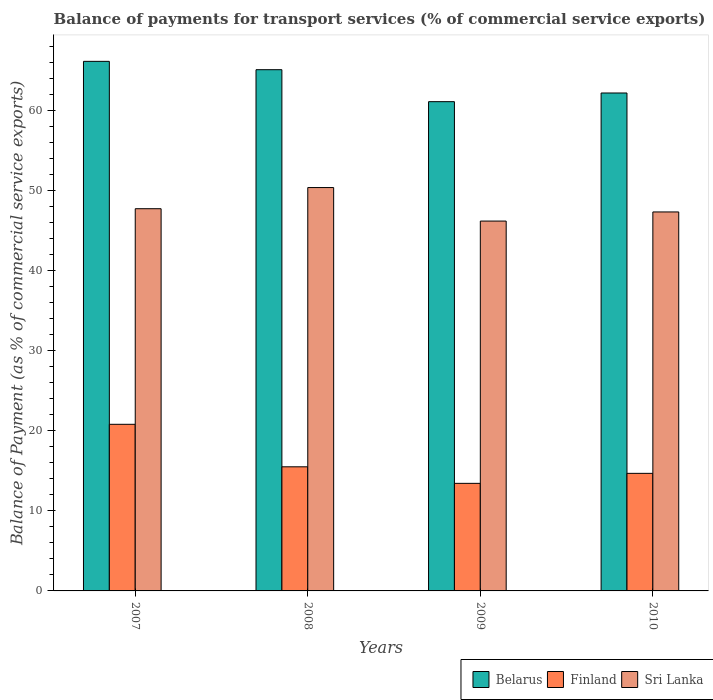Are the number of bars on each tick of the X-axis equal?
Your answer should be compact. Yes. How many bars are there on the 3rd tick from the right?
Provide a succinct answer. 3. What is the label of the 1st group of bars from the left?
Offer a very short reply. 2007. In how many cases, is the number of bars for a given year not equal to the number of legend labels?
Your answer should be very brief. 0. What is the balance of payments for transport services in Finland in 2007?
Provide a short and direct response. 20.81. Across all years, what is the maximum balance of payments for transport services in Sri Lanka?
Make the answer very short. 50.39. Across all years, what is the minimum balance of payments for transport services in Belarus?
Provide a short and direct response. 61.12. In which year was the balance of payments for transport services in Sri Lanka maximum?
Ensure brevity in your answer.  2008. What is the total balance of payments for transport services in Belarus in the graph?
Offer a very short reply. 254.58. What is the difference between the balance of payments for transport services in Finland in 2009 and that in 2010?
Give a very brief answer. -1.25. What is the difference between the balance of payments for transport services in Belarus in 2008 and the balance of payments for transport services in Sri Lanka in 2009?
Make the answer very short. 18.91. What is the average balance of payments for transport services in Belarus per year?
Offer a terse response. 63.65. In the year 2007, what is the difference between the balance of payments for transport services in Sri Lanka and balance of payments for transport services in Finland?
Offer a terse response. 26.93. What is the ratio of the balance of payments for transport services in Belarus in 2007 to that in 2009?
Your answer should be compact. 1.08. Is the balance of payments for transport services in Sri Lanka in 2007 less than that in 2010?
Offer a terse response. No. Is the difference between the balance of payments for transport services in Sri Lanka in 2007 and 2009 greater than the difference between the balance of payments for transport services in Finland in 2007 and 2009?
Give a very brief answer. No. What is the difference between the highest and the second highest balance of payments for transport services in Sri Lanka?
Provide a succinct answer. 2.64. What is the difference between the highest and the lowest balance of payments for transport services in Finland?
Offer a terse response. 7.38. What does the 3rd bar from the right in 2007 represents?
Your answer should be very brief. Belarus. Is it the case that in every year, the sum of the balance of payments for transport services in Belarus and balance of payments for transport services in Sri Lanka is greater than the balance of payments for transport services in Finland?
Your answer should be compact. Yes. How many bars are there?
Provide a short and direct response. 12. What is the difference between two consecutive major ticks on the Y-axis?
Give a very brief answer. 10. What is the title of the graph?
Provide a short and direct response. Balance of payments for transport services (% of commercial service exports). Does "Venezuela" appear as one of the legend labels in the graph?
Your response must be concise. No. What is the label or title of the X-axis?
Provide a succinct answer. Years. What is the label or title of the Y-axis?
Provide a succinct answer. Balance of Payment (as % of commercial service exports). What is the Balance of Payment (as % of commercial service exports) in Belarus in 2007?
Your answer should be compact. 66.15. What is the Balance of Payment (as % of commercial service exports) in Finland in 2007?
Make the answer very short. 20.81. What is the Balance of Payment (as % of commercial service exports) in Sri Lanka in 2007?
Offer a very short reply. 47.75. What is the Balance of Payment (as % of commercial service exports) in Belarus in 2008?
Your answer should be very brief. 65.11. What is the Balance of Payment (as % of commercial service exports) in Finland in 2008?
Make the answer very short. 15.5. What is the Balance of Payment (as % of commercial service exports) of Sri Lanka in 2008?
Your answer should be compact. 50.39. What is the Balance of Payment (as % of commercial service exports) of Belarus in 2009?
Your answer should be compact. 61.12. What is the Balance of Payment (as % of commercial service exports) of Finland in 2009?
Your response must be concise. 13.44. What is the Balance of Payment (as % of commercial service exports) in Sri Lanka in 2009?
Give a very brief answer. 46.2. What is the Balance of Payment (as % of commercial service exports) in Belarus in 2010?
Your answer should be very brief. 62.2. What is the Balance of Payment (as % of commercial service exports) in Finland in 2010?
Ensure brevity in your answer.  14.69. What is the Balance of Payment (as % of commercial service exports) in Sri Lanka in 2010?
Provide a short and direct response. 47.34. Across all years, what is the maximum Balance of Payment (as % of commercial service exports) of Belarus?
Give a very brief answer. 66.15. Across all years, what is the maximum Balance of Payment (as % of commercial service exports) of Finland?
Offer a terse response. 20.81. Across all years, what is the maximum Balance of Payment (as % of commercial service exports) of Sri Lanka?
Your response must be concise. 50.39. Across all years, what is the minimum Balance of Payment (as % of commercial service exports) of Belarus?
Your answer should be very brief. 61.12. Across all years, what is the minimum Balance of Payment (as % of commercial service exports) in Finland?
Provide a succinct answer. 13.44. Across all years, what is the minimum Balance of Payment (as % of commercial service exports) of Sri Lanka?
Provide a succinct answer. 46.2. What is the total Balance of Payment (as % of commercial service exports) in Belarus in the graph?
Your response must be concise. 254.58. What is the total Balance of Payment (as % of commercial service exports) in Finland in the graph?
Keep it short and to the point. 64.44. What is the total Balance of Payment (as % of commercial service exports) in Sri Lanka in the graph?
Provide a short and direct response. 191.68. What is the difference between the Balance of Payment (as % of commercial service exports) in Belarus in 2007 and that in 2008?
Make the answer very short. 1.04. What is the difference between the Balance of Payment (as % of commercial service exports) in Finland in 2007 and that in 2008?
Offer a very short reply. 5.31. What is the difference between the Balance of Payment (as % of commercial service exports) of Sri Lanka in 2007 and that in 2008?
Your response must be concise. -2.64. What is the difference between the Balance of Payment (as % of commercial service exports) of Belarus in 2007 and that in 2009?
Provide a short and direct response. 5.04. What is the difference between the Balance of Payment (as % of commercial service exports) in Finland in 2007 and that in 2009?
Your answer should be very brief. 7.38. What is the difference between the Balance of Payment (as % of commercial service exports) in Sri Lanka in 2007 and that in 2009?
Provide a short and direct response. 1.54. What is the difference between the Balance of Payment (as % of commercial service exports) of Belarus in 2007 and that in 2010?
Provide a succinct answer. 3.95. What is the difference between the Balance of Payment (as % of commercial service exports) of Finland in 2007 and that in 2010?
Give a very brief answer. 6.13. What is the difference between the Balance of Payment (as % of commercial service exports) of Sri Lanka in 2007 and that in 2010?
Your response must be concise. 0.4. What is the difference between the Balance of Payment (as % of commercial service exports) in Belarus in 2008 and that in 2009?
Offer a very short reply. 3.99. What is the difference between the Balance of Payment (as % of commercial service exports) of Finland in 2008 and that in 2009?
Give a very brief answer. 2.07. What is the difference between the Balance of Payment (as % of commercial service exports) of Sri Lanka in 2008 and that in 2009?
Keep it short and to the point. 4.19. What is the difference between the Balance of Payment (as % of commercial service exports) in Belarus in 2008 and that in 2010?
Keep it short and to the point. 2.91. What is the difference between the Balance of Payment (as % of commercial service exports) in Finland in 2008 and that in 2010?
Make the answer very short. 0.82. What is the difference between the Balance of Payment (as % of commercial service exports) of Sri Lanka in 2008 and that in 2010?
Offer a very short reply. 3.05. What is the difference between the Balance of Payment (as % of commercial service exports) in Belarus in 2009 and that in 2010?
Offer a terse response. -1.08. What is the difference between the Balance of Payment (as % of commercial service exports) in Finland in 2009 and that in 2010?
Your response must be concise. -1.25. What is the difference between the Balance of Payment (as % of commercial service exports) of Sri Lanka in 2009 and that in 2010?
Offer a very short reply. -1.14. What is the difference between the Balance of Payment (as % of commercial service exports) in Belarus in 2007 and the Balance of Payment (as % of commercial service exports) in Finland in 2008?
Offer a terse response. 50.65. What is the difference between the Balance of Payment (as % of commercial service exports) of Belarus in 2007 and the Balance of Payment (as % of commercial service exports) of Sri Lanka in 2008?
Make the answer very short. 15.77. What is the difference between the Balance of Payment (as % of commercial service exports) in Finland in 2007 and the Balance of Payment (as % of commercial service exports) in Sri Lanka in 2008?
Offer a very short reply. -29.57. What is the difference between the Balance of Payment (as % of commercial service exports) in Belarus in 2007 and the Balance of Payment (as % of commercial service exports) in Finland in 2009?
Your response must be concise. 52.72. What is the difference between the Balance of Payment (as % of commercial service exports) in Belarus in 2007 and the Balance of Payment (as % of commercial service exports) in Sri Lanka in 2009?
Offer a very short reply. 19.95. What is the difference between the Balance of Payment (as % of commercial service exports) in Finland in 2007 and the Balance of Payment (as % of commercial service exports) in Sri Lanka in 2009?
Ensure brevity in your answer.  -25.39. What is the difference between the Balance of Payment (as % of commercial service exports) in Belarus in 2007 and the Balance of Payment (as % of commercial service exports) in Finland in 2010?
Your response must be concise. 51.47. What is the difference between the Balance of Payment (as % of commercial service exports) of Belarus in 2007 and the Balance of Payment (as % of commercial service exports) of Sri Lanka in 2010?
Make the answer very short. 18.81. What is the difference between the Balance of Payment (as % of commercial service exports) of Finland in 2007 and the Balance of Payment (as % of commercial service exports) of Sri Lanka in 2010?
Provide a succinct answer. -26.53. What is the difference between the Balance of Payment (as % of commercial service exports) in Belarus in 2008 and the Balance of Payment (as % of commercial service exports) in Finland in 2009?
Keep it short and to the point. 51.67. What is the difference between the Balance of Payment (as % of commercial service exports) of Belarus in 2008 and the Balance of Payment (as % of commercial service exports) of Sri Lanka in 2009?
Ensure brevity in your answer.  18.91. What is the difference between the Balance of Payment (as % of commercial service exports) of Finland in 2008 and the Balance of Payment (as % of commercial service exports) of Sri Lanka in 2009?
Offer a very short reply. -30.7. What is the difference between the Balance of Payment (as % of commercial service exports) of Belarus in 2008 and the Balance of Payment (as % of commercial service exports) of Finland in 2010?
Your answer should be very brief. 50.43. What is the difference between the Balance of Payment (as % of commercial service exports) of Belarus in 2008 and the Balance of Payment (as % of commercial service exports) of Sri Lanka in 2010?
Keep it short and to the point. 17.77. What is the difference between the Balance of Payment (as % of commercial service exports) in Finland in 2008 and the Balance of Payment (as % of commercial service exports) in Sri Lanka in 2010?
Your answer should be compact. -31.84. What is the difference between the Balance of Payment (as % of commercial service exports) of Belarus in 2009 and the Balance of Payment (as % of commercial service exports) of Finland in 2010?
Offer a terse response. 46.43. What is the difference between the Balance of Payment (as % of commercial service exports) in Belarus in 2009 and the Balance of Payment (as % of commercial service exports) in Sri Lanka in 2010?
Give a very brief answer. 13.78. What is the difference between the Balance of Payment (as % of commercial service exports) of Finland in 2009 and the Balance of Payment (as % of commercial service exports) of Sri Lanka in 2010?
Offer a terse response. -33.9. What is the average Balance of Payment (as % of commercial service exports) of Belarus per year?
Your answer should be compact. 63.65. What is the average Balance of Payment (as % of commercial service exports) of Finland per year?
Offer a very short reply. 16.11. What is the average Balance of Payment (as % of commercial service exports) in Sri Lanka per year?
Make the answer very short. 47.92. In the year 2007, what is the difference between the Balance of Payment (as % of commercial service exports) in Belarus and Balance of Payment (as % of commercial service exports) in Finland?
Ensure brevity in your answer.  45.34. In the year 2007, what is the difference between the Balance of Payment (as % of commercial service exports) of Belarus and Balance of Payment (as % of commercial service exports) of Sri Lanka?
Provide a succinct answer. 18.41. In the year 2007, what is the difference between the Balance of Payment (as % of commercial service exports) in Finland and Balance of Payment (as % of commercial service exports) in Sri Lanka?
Provide a succinct answer. -26.93. In the year 2008, what is the difference between the Balance of Payment (as % of commercial service exports) in Belarus and Balance of Payment (as % of commercial service exports) in Finland?
Offer a terse response. 49.61. In the year 2008, what is the difference between the Balance of Payment (as % of commercial service exports) in Belarus and Balance of Payment (as % of commercial service exports) in Sri Lanka?
Your answer should be very brief. 14.72. In the year 2008, what is the difference between the Balance of Payment (as % of commercial service exports) of Finland and Balance of Payment (as % of commercial service exports) of Sri Lanka?
Offer a terse response. -34.88. In the year 2009, what is the difference between the Balance of Payment (as % of commercial service exports) in Belarus and Balance of Payment (as % of commercial service exports) in Finland?
Provide a short and direct response. 47.68. In the year 2009, what is the difference between the Balance of Payment (as % of commercial service exports) of Belarus and Balance of Payment (as % of commercial service exports) of Sri Lanka?
Your answer should be very brief. 14.92. In the year 2009, what is the difference between the Balance of Payment (as % of commercial service exports) in Finland and Balance of Payment (as % of commercial service exports) in Sri Lanka?
Your answer should be compact. -32.77. In the year 2010, what is the difference between the Balance of Payment (as % of commercial service exports) of Belarus and Balance of Payment (as % of commercial service exports) of Finland?
Provide a short and direct response. 47.51. In the year 2010, what is the difference between the Balance of Payment (as % of commercial service exports) of Belarus and Balance of Payment (as % of commercial service exports) of Sri Lanka?
Ensure brevity in your answer.  14.86. In the year 2010, what is the difference between the Balance of Payment (as % of commercial service exports) of Finland and Balance of Payment (as % of commercial service exports) of Sri Lanka?
Ensure brevity in your answer.  -32.66. What is the ratio of the Balance of Payment (as % of commercial service exports) of Finland in 2007 to that in 2008?
Your response must be concise. 1.34. What is the ratio of the Balance of Payment (as % of commercial service exports) of Sri Lanka in 2007 to that in 2008?
Give a very brief answer. 0.95. What is the ratio of the Balance of Payment (as % of commercial service exports) in Belarus in 2007 to that in 2009?
Provide a succinct answer. 1.08. What is the ratio of the Balance of Payment (as % of commercial service exports) in Finland in 2007 to that in 2009?
Provide a short and direct response. 1.55. What is the ratio of the Balance of Payment (as % of commercial service exports) of Sri Lanka in 2007 to that in 2009?
Provide a succinct answer. 1.03. What is the ratio of the Balance of Payment (as % of commercial service exports) of Belarus in 2007 to that in 2010?
Ensure brevity in your answer.  1.06. What is the ratio of the Balance of Payment (as % of commercial service exports) in Finland in 2007 to that in 2010?
Give a very brief answer. 1.42. What is the ratio of the Balance of Payment (as % of commercial service exports) in Sri Lanka in 2007 to that in 2010?
Give a very brief answer. 1.01. What is the ratio of the Balance of Payment (as % of commercial service exports) in Belarus in 2008 to that in 2009?
Provide a succinct answer. 1.07. What is the ratio of the Balance of Payment (as % of commercial service exports) in Finland in 2008 to that in 2009?
Your answer should be compact. 1.15. What is the ratio of the Balance of Payment (as % of commercial service exports) in Sri Lanka in 2008 to that in 2009?
Offer a very short reply. 1.09. What is the ratio of the Balance of Payment (as % of commercial service exports) in Belarus in 2008 to that in 2010?
Ensure brevity in your answer.  1.05. What is the ratio of the Balance of Payment (as % of commercial service exports) of Finland in 2008 to that in 2010?
Make the answer very short. 1.06. What is the ratio of the Balance of Payment (as % of commercial service exports) in Sri Lanka in 2008 to that in 2010?
Give a very brief answer. 1.06. What is the ratio of the Balance of Payment (as % of commercial service exports) in Belarus in 2009 to that in 2010?
Your answer should be compact. 0.98. What is the ratio of the Balance of Payment (as % of commercial service exports) in Finland in 2009 to that in 2010?
Ensure brevity in your answer.  0.91. What is the ratio of the Balance of Payment (as % of commercial service exports) of Sri Lanka in 2009 to that in 2010?
Your answer should be compact. 0.98. What is the difference between the highest and the second highest Balance of Payment (as % of commercial service exports) of Belarus?
Your response must be concise. 1.04. What is the difference between the highest and the second highest Balance of Payment (as % of commercial service exports) in Finland?
Make the answer very short. 5.31. What is the difference between the highest and the second highest Balance of Payment (as % of commercial service exports) of Sri Lanka?
Your answer should be compact. 2.64. What is the difference between the highest and the lowest Balance of Payment (as % of commercial service exports) in Belarus?
Ensure brevity in your answer.  5.04. What is the difference between the highest and the lowest Balance of Payment (as % of commercial service exports) in Finland?
Keep it short and to the point. 7.38. What is the difference between the highest and the lowest Balance of Payment (as % of commercial service exports) of Sri Lanka?
Offer a terse response. 4.19. 